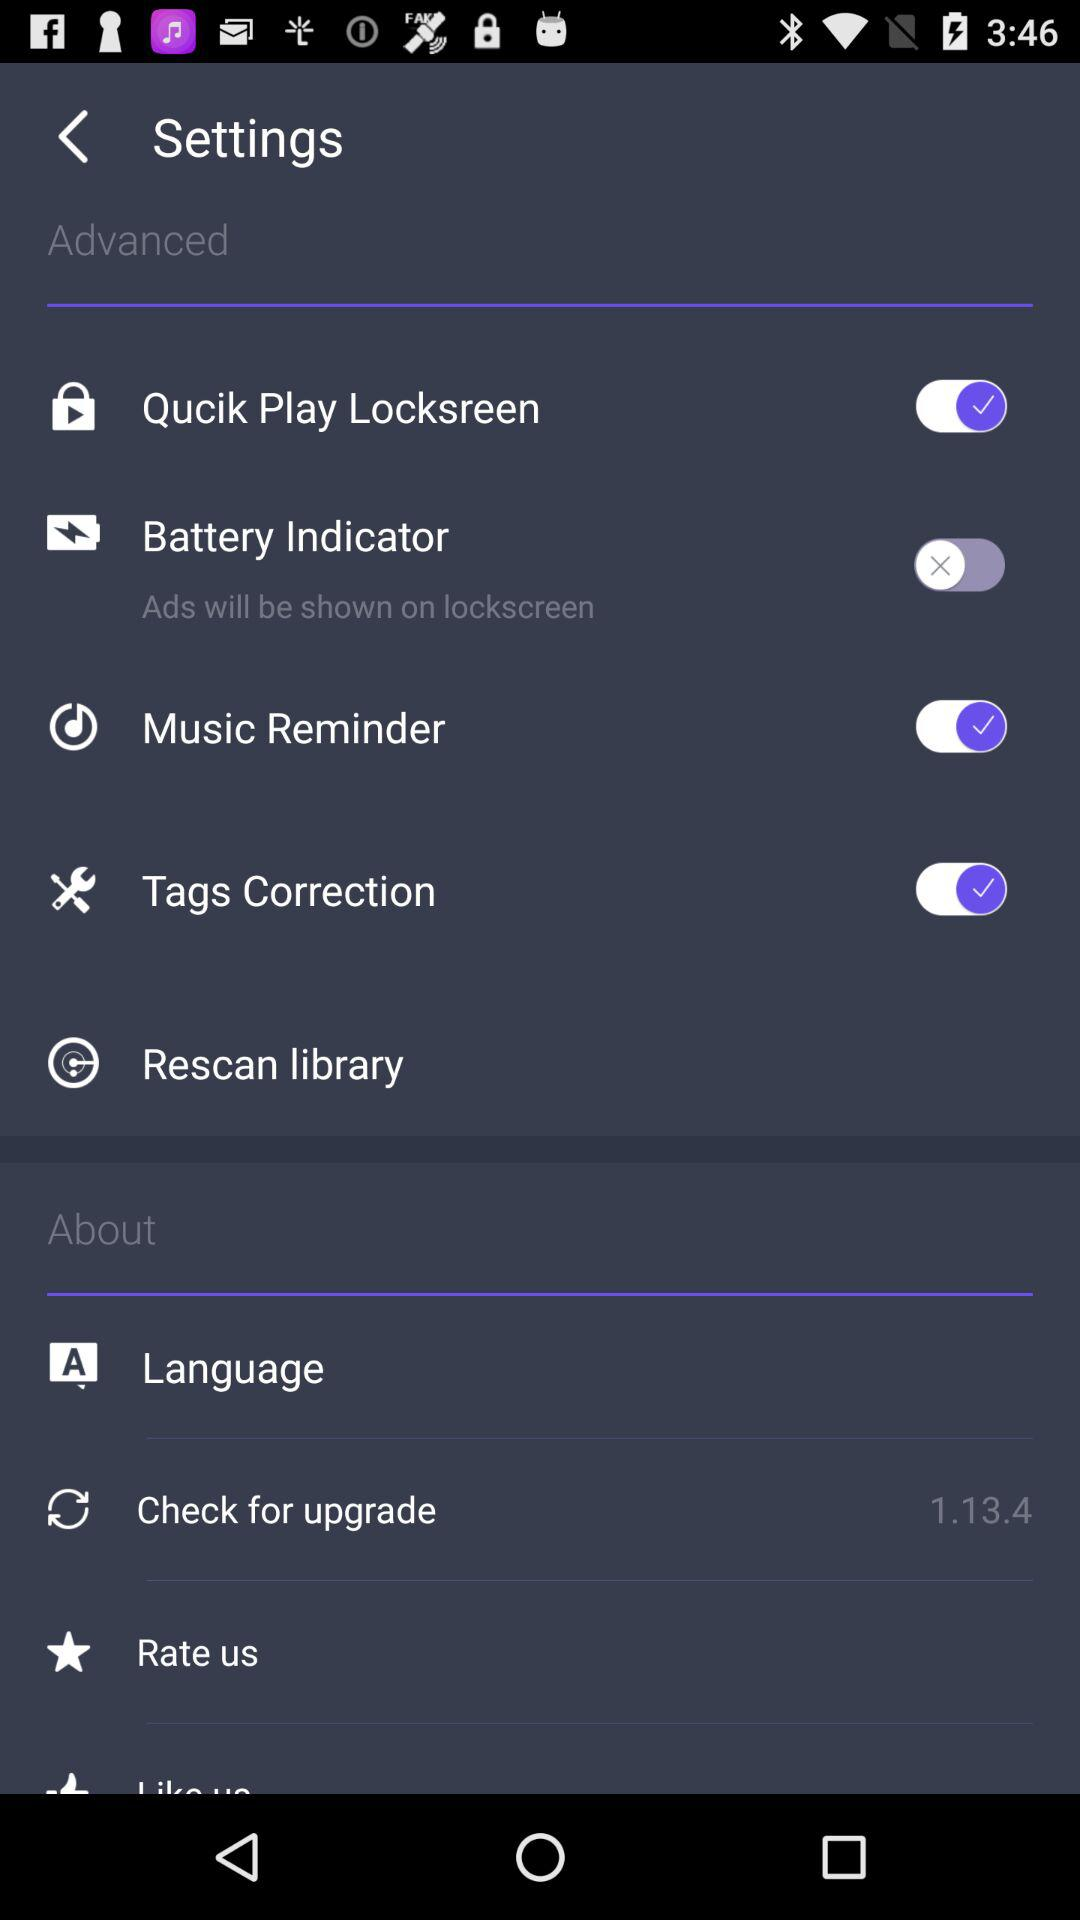How many items are in the settings menu that have a switch?
Answer the question using a single word or phrase. 4 